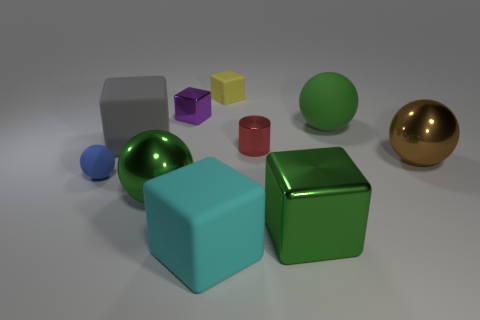What is the size of the rubber ball that is the same color as the big metal block?
Your answer should be compact. Large. How many big balls are the same color as the large metallic cube?
Make the answer very short. 2. What is the tiny red thing made of?
Offer a terse response. Metal. Does the gray thing have the same shape as the large green matte thing?
Offer a very short reply. No. Are there any big green cylinders that have the same material as the yellow block?
Ensure brevity in your answer.  No. The thing that is both right of the tiny red metal object and in front of the tiny matte sphere is what color?
Your response must be concise. Green. There is a green ball that is on the left side of the tiny red metal cylinder; what material is it?
Your response must be concise. Metal. Is there a green metallic object of the same shape as the blue rubber object?
Provide a short and direct response. Yes. What number of other things are there of the same shape as the small blue object?
Make the answer very short. 3. There is a blue matte object; does it have the same shape as the large green metallic object left of the small cylinder?
Make the answer very short. Yes. 